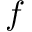<formula> <loc_0><loc_0><loc_500><loc_500>f</formula> 